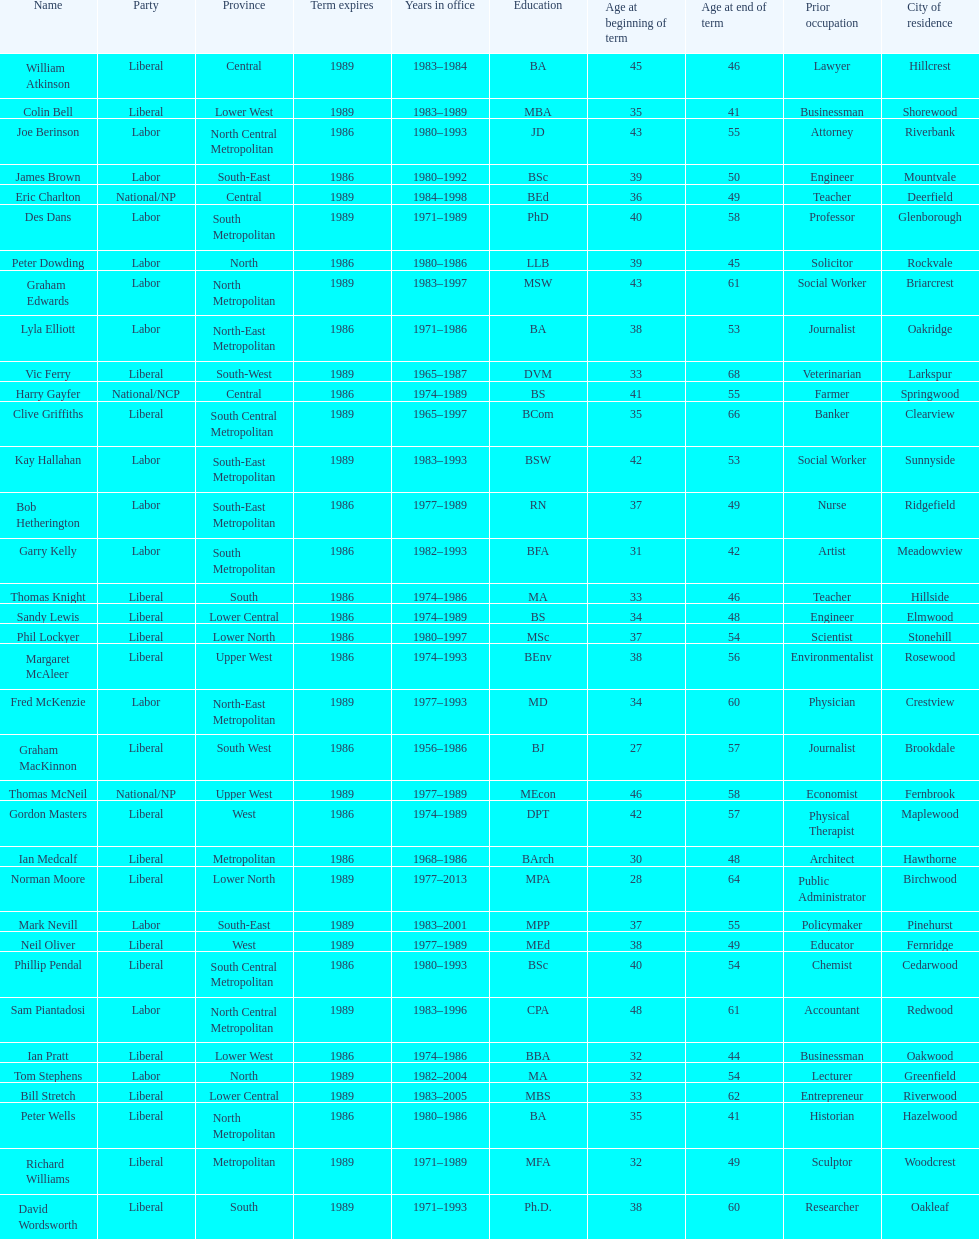Who has had the shortest term in office William Atkinson. 